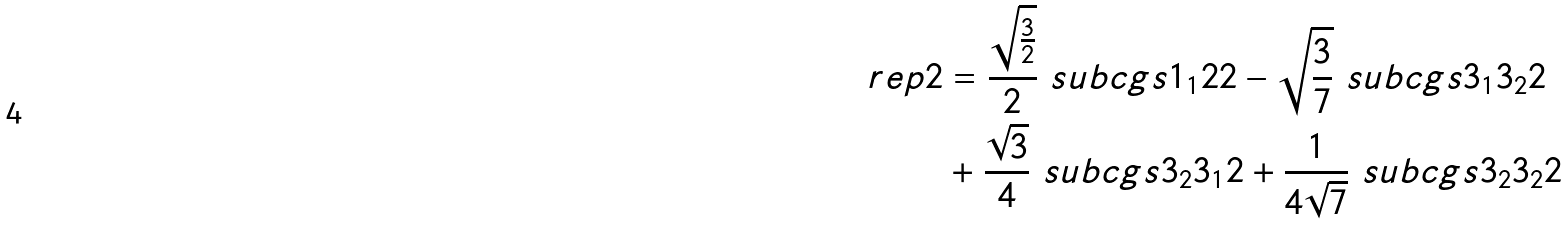Convert formula to latex. <formula><loc_0><loc_0><loc_500><loc_500>\ r e p { 2 } & = \frac { \sqrt { \frac { 3 } { 2 } } } { 2 } \ s u b c g s { 1 _ { 1 } } { 2 } { 2 } - \sqrt { \frac { 3 } { 7 } } \ s u b c g s { 3 _ { 1 } } { 3 _ { 2 } } { 2 } \\ & + \frac { \sqrt { 3 } } { 4 } \ s u b c g s { 3 _ { 2 } } { 3 _ { 1 } } { 2 } + \frac { 1 } { 4 \sqrt { 7 } } \ s u b c g s { 3 _ { 2 } } { 3 _ { 2 } } { 2 }</formula> 